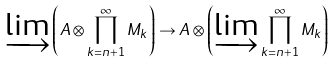<formula> <loc_0><loc_0><loc_500><loc_500>\varinjlim \left ( A \otimes \prod _ { k = n + 1 } ^ { \infty } M _ { k } \right ) \to A \otimes \left ( \varinjlim \prod _ { k = n + 1 } ^ { \infty } M _ { k } \right )</formula> 